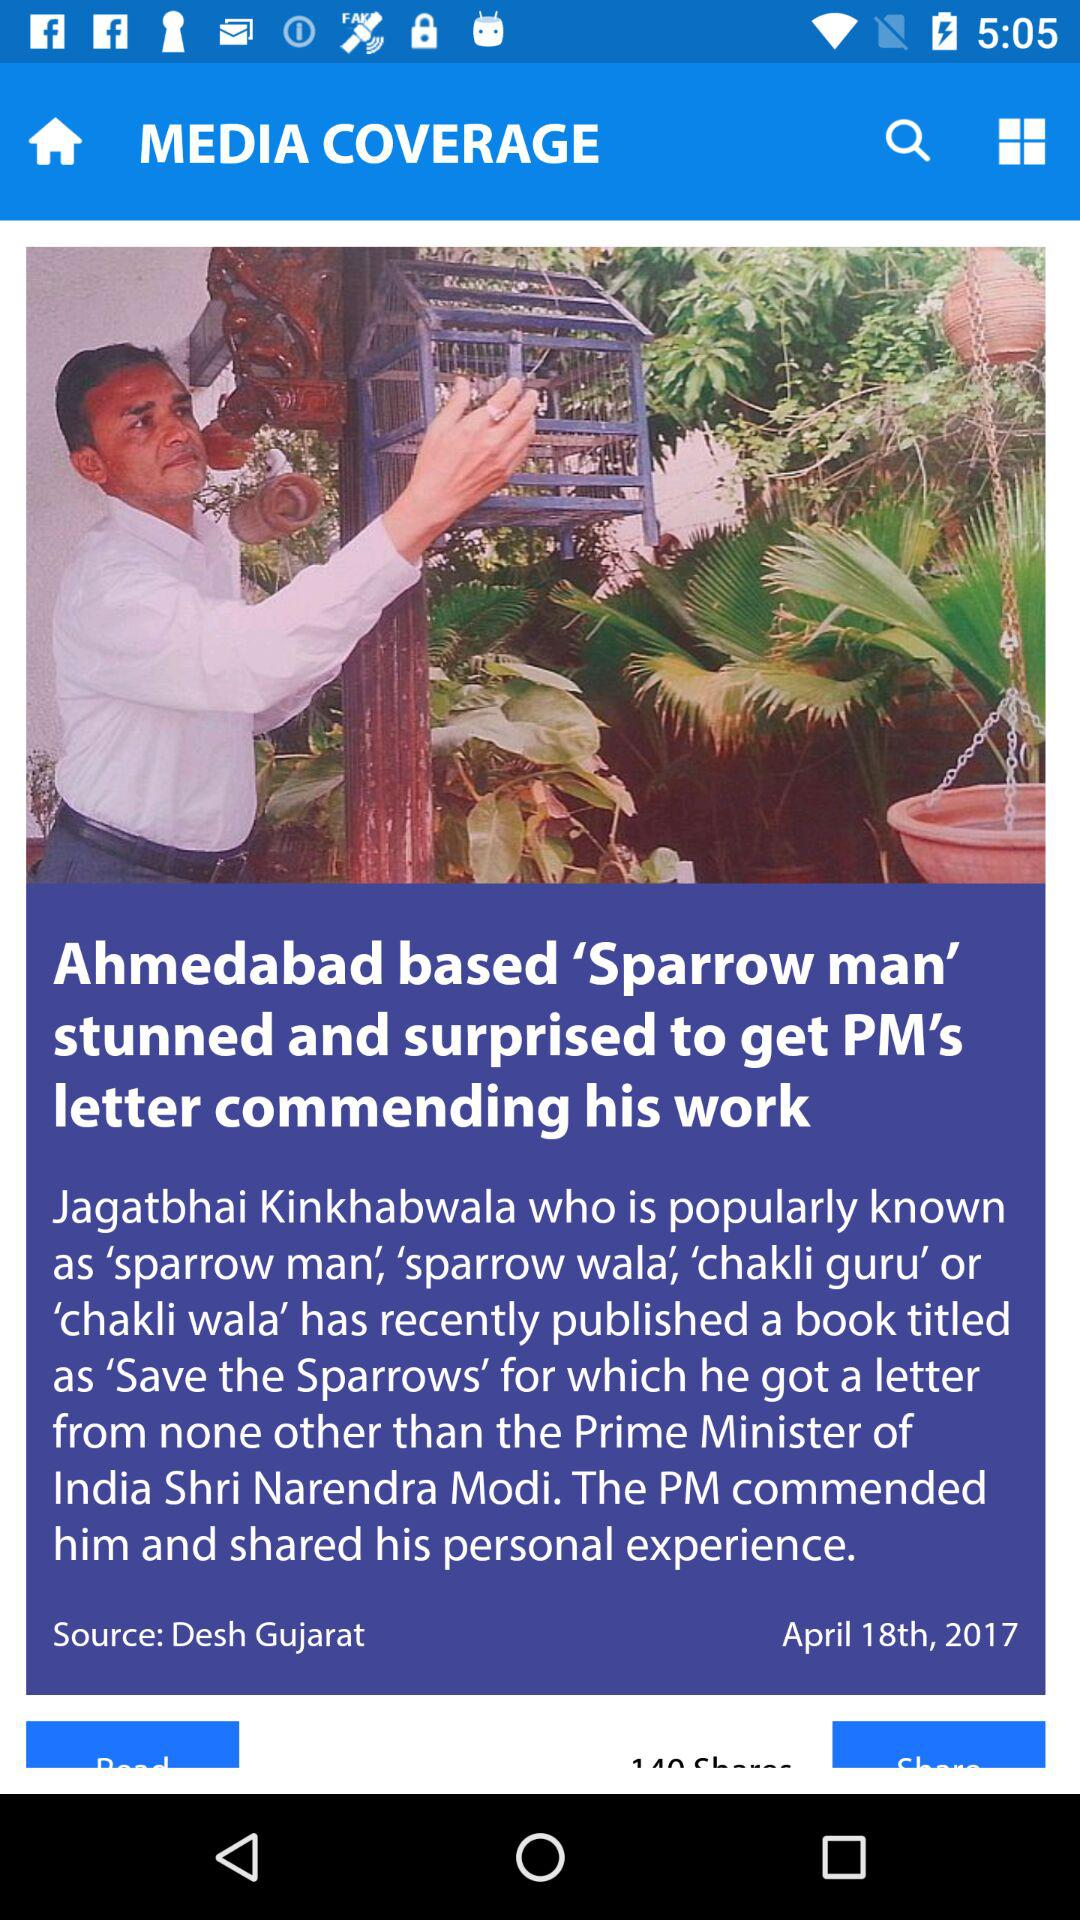On what date was the news published? The news was published on April 18th, 2017. 